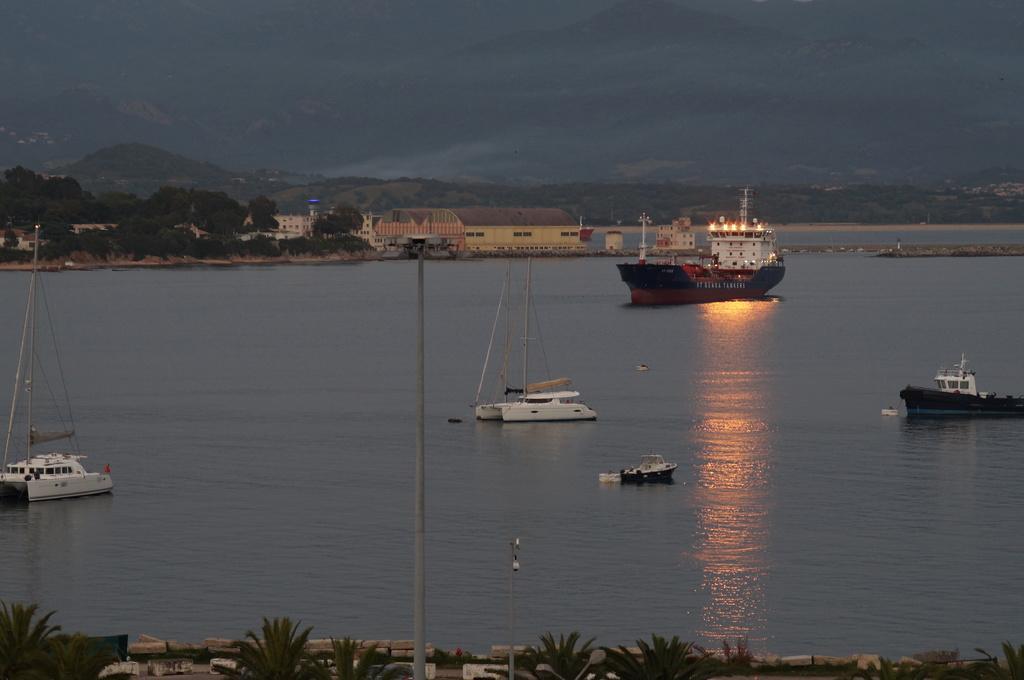Please provide a concise description of this image. In this image we can see boats and also ships on the surface of the water. Image also consists of many trees and also buildings. Light poles are also visible in this image. 